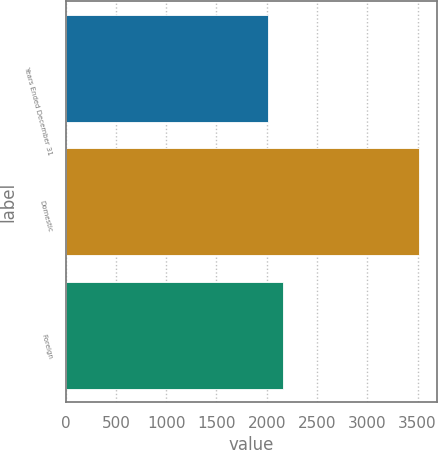<chart> <loc_0><loc_0><loc_500><loc_500><bar_chart><fcel>Years Ended December 31<fcel>Domestic<fcel>Foreign<nl><fcel>2013<fcel>3513<fcel>2163<nl></chart> 